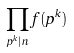Convert formula to latex. <formula><loc_0><loc_0><loc_500><loc_500>\prod _ { p ^ { k } | n } f ( p ^ { k } )</formula> 